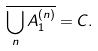<formula> <loc_0><loc_0><loc_500><loc_500>\overline { \bigcup _ { n } A _ { 1 } ^ { ( n ) } } = C .</formula> 